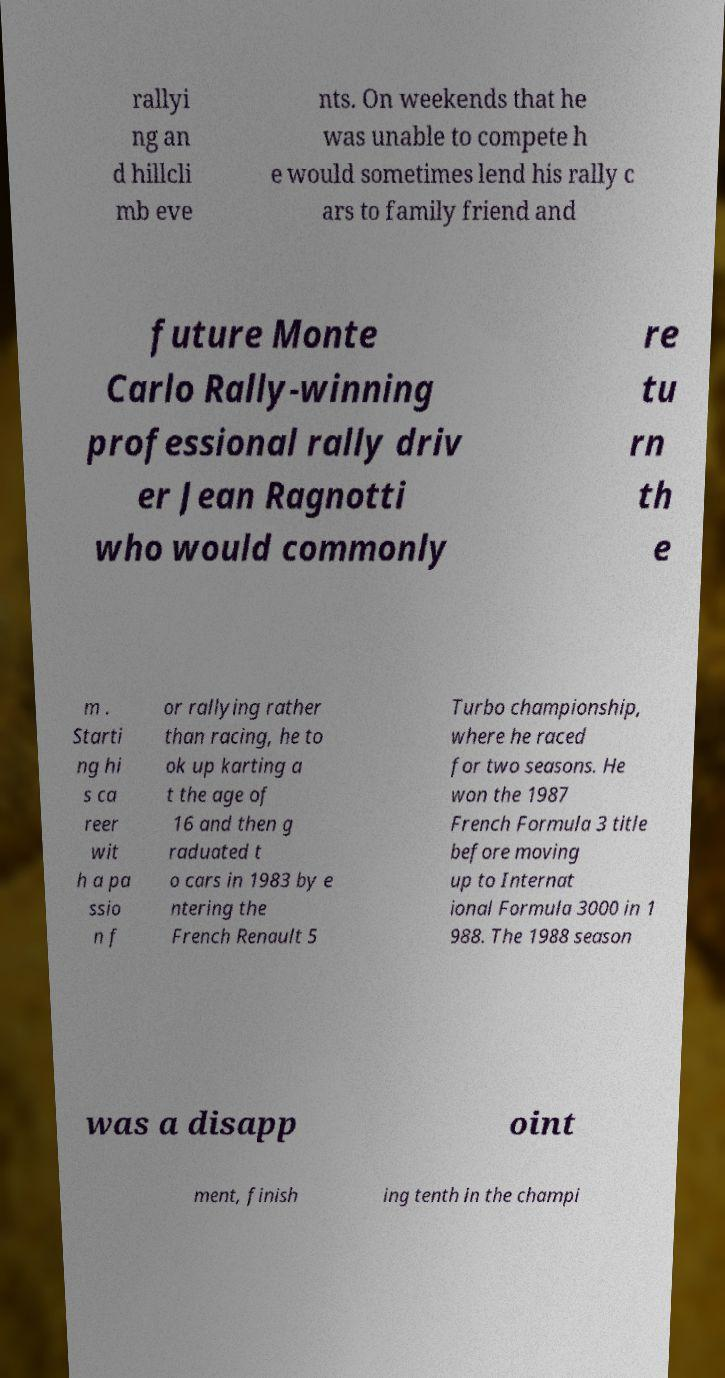Can you read and provide the text displayed in the image?This photo seems to have some interesting text. Can you extract and type it out for me? rallyi ng an d hillcli mb eve nts. On weekends that he was unable to compete h e would sometimes lend his rally c ars to family friend and future Monte Carlo Rally-winning professional rally driv er Jean Ragnotti who would commonly re tu rn th e m . Starti ng hi s ca reer wit h a pa ssio n f or rallying rather than racing, he to ok up karting a t the age of 16 and then g raduated t o cars in 1983 by e ntering the French Renault 5 Turbo championship, where he raced for two seasons. He won the 1987 French Formula 3 title before moving up to Internat ional Formula 3000 in 1 988. The 1988 season was a disapp oint ment, finish ing tenth in the champi 